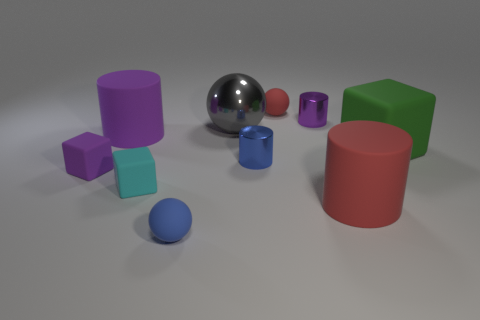What number of metallic objects are red cylinders or small blue balls?
Provide a succinct answer. 0. What shape is the gray object?
Keep it short and to the point. Sphere. What number of things are the same material as the large gray sphere?
Your response must be concise. 2. There is a big cube that is made of the same material as the small blue sphere; what color is it?
Provide a succinct answer. Green. Does the purple cylinder to the left of the cyan matte block have the same size as the small purple shiny object?
Your answer should be very brief. No. The other big thing that is the same shape as the big red matte object is what color?
Give a very brief answer. Purple. There is a small purple object on the left side of the small sphere behind the thing that is in front of the large red thing; what is its shape?
Offer a very short reply. Cube. Is the large purple object the same shape as the purple shiny thing?
Your response must be concise. Yes. There is a tiny purple thing that is on the right side of the rubber ball to the right of the tiny blue rubber ball; what is its shape?
Your answer should be compact. Cylinder. Is there a green cube?
Give a very brief answer. Yes. 